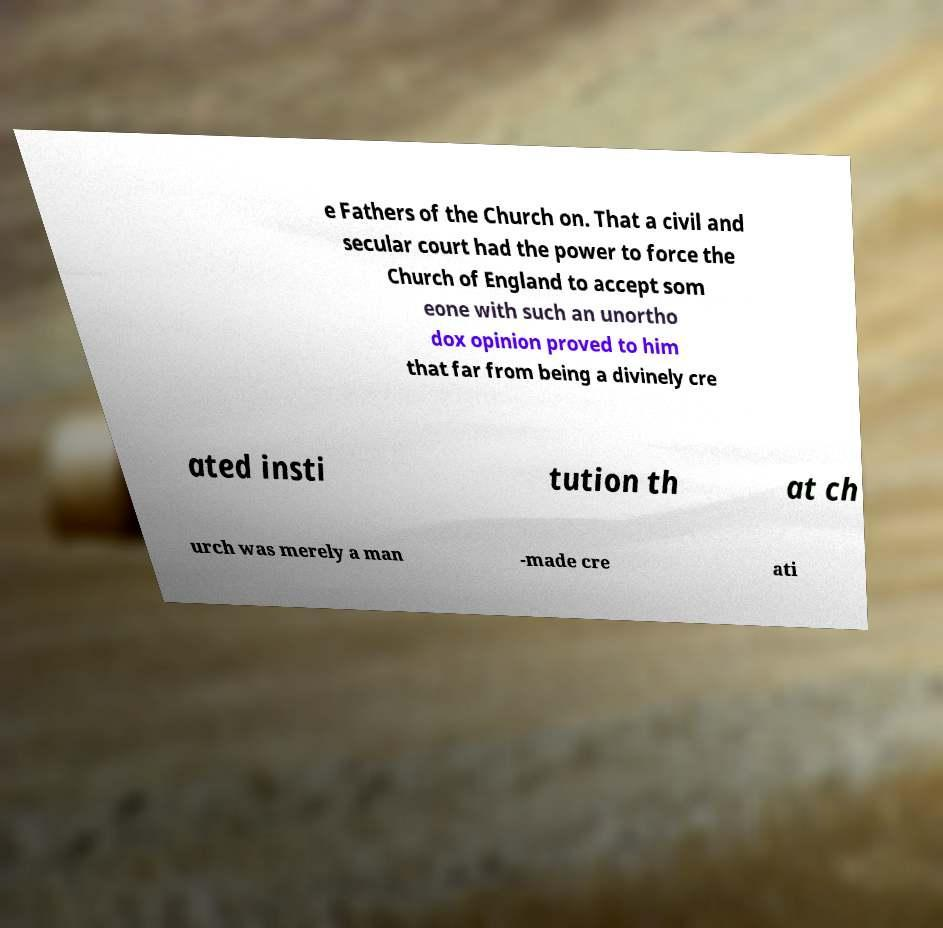I need the written content from this picture converted into text. Can you do that? e Fathers of the Church on. That a civil and secular court had the power to force the Church of England to accept som eone with such an unortho dox opinion proved to him that far from being a divinely cre ated insti tution th at ch urch was merely a man -made cre ati 